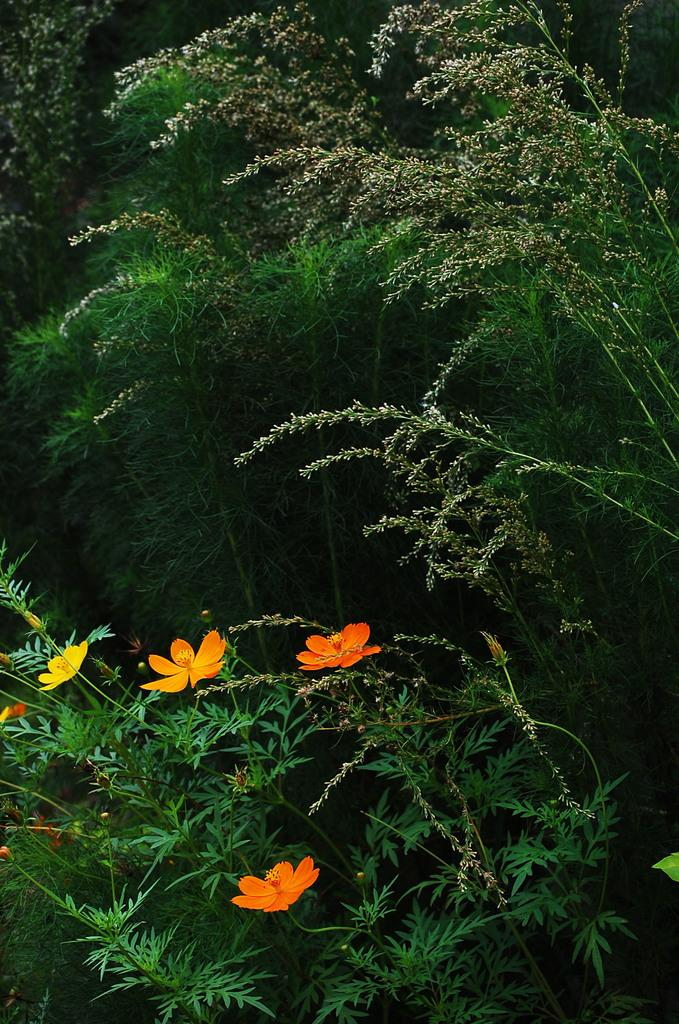What is located in the foreground of the image? There are flowers in the foreground of the image. What type of living organisms are the flowers associated with? The flowers are associated with plants. What can be seen in the background of the image? There are trees in the background of the image. What type of protest is taking place in the image? There is no protest present in the image; it features flowers in the foreground and trees in the background. Can you tell me how many horses are visible in the image? There are no horses present in the image. 